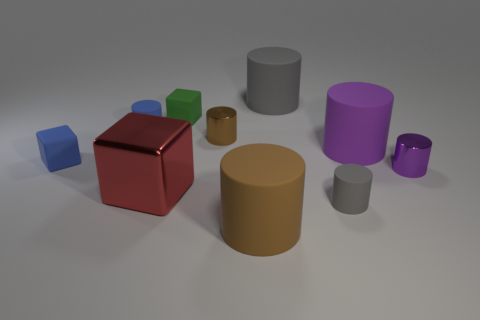Subtract 4 cylinders. How many cylinders are left? 3 Subtract all brown cylinders. How many cylinders are left? 5 Subtract all purple cylinders. How many cylinders are left? 5 Subtract all gray cylinders. Subtract all brown blocks. How many cylinders are left? 5 Subtract all cubes. How many objects are left? 7 Add 5 purple metallic objects. How many purple metallic objects are left? 6 Add 5 metal cubes. How many metal cubes exist? 6 Subtract 0 blue balls. How many objects are left? 10 Subtract all small blocks. Subtract all tiny green rubber blocks. How many objects are left? 7 